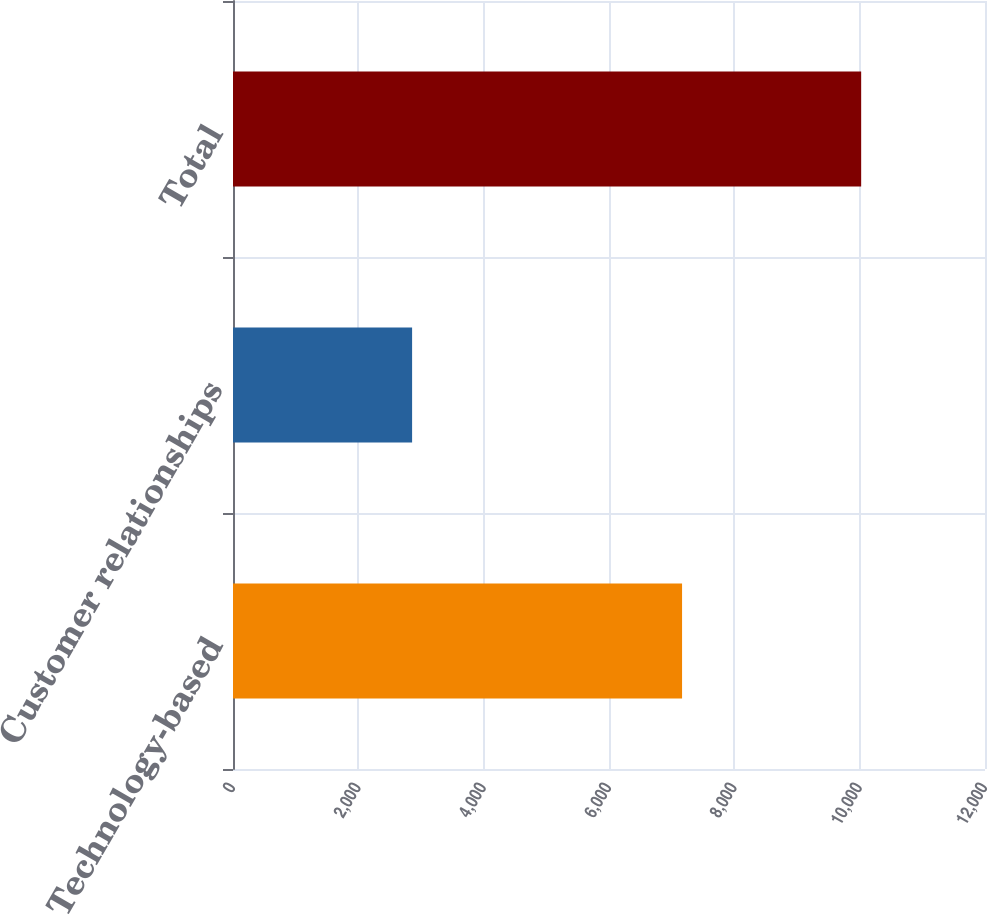Convert chart to OTSL. <chart><loc_0><loc_0><loc_500><loc_500><bar_chart><fcel>Technology-based<fcel>Customer relationships<fcel>Total<nl><fcel>7166<fcel>2858<fcel>10024<nl></chart> 